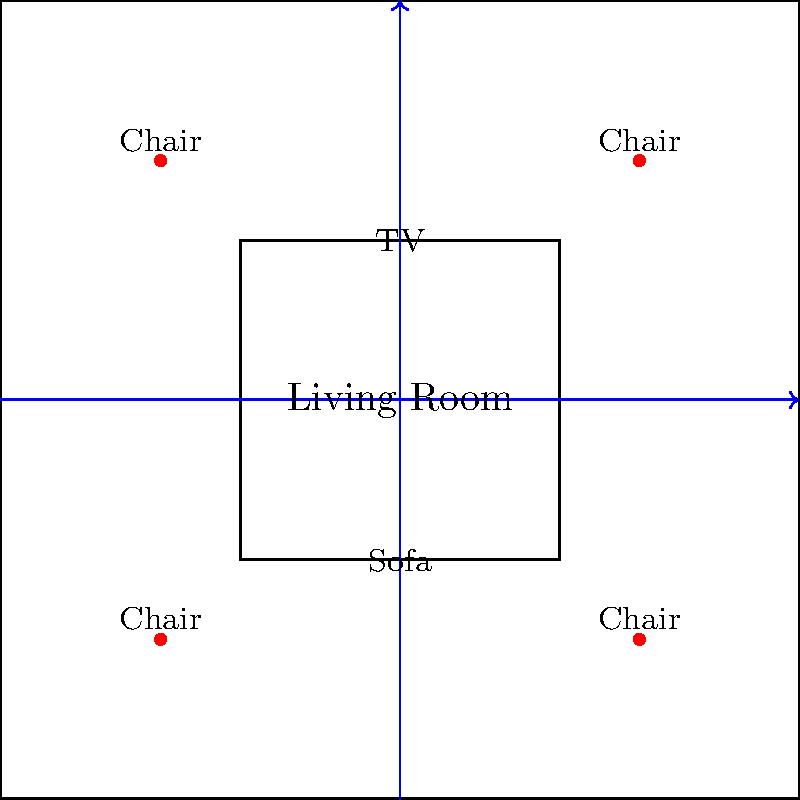In a rectangular living room measuring 100 units by 100 units, a central seating area is defined by a sofa (40 units wide) and a TV stand (40 units wide) placed opposite each other. Four chairs are positioned in the corners of the room. Given that the main traffic flow is along the two perpendicular paths that bisect the room, calculate the total area (in square units) of the optimal traffic zones to maximize flow efficiency while maintaining the current furniture layout. To solve this problem, we'll follow these steps:

1. Identify the main traffic paths:
   The two perpendicular paths bisect the room, creating four equal quadrants.

2. Determine the width of the traffic paths:
   Given the room dimensions and furniture placement, we can assume a reasonable width for the traffic paths. Let's use 20 units, which allows comfortable passage without disturbing the seating arrangement.

3. Calculate the area of the traffic zones:
   a) Area of horizontal path = 100 units × 20 units = 2000 square units
   b) Area of vertical path = 100 units × 20 units = 2000 square units
   c) However, the intersection of these paths is counted twice, so we need to subtract it:
      Intersection area = 20 units × 20 units = 400 square units

4. Calculate the total optimal traffic zone area:
   Total area = Horizontal path + Vertical path - Intersection
               = 2000 + 2000 - 400
               = 3600 square units

This layout ensures efficient traffic flow while maintaining the current furniture arrangement. The 20-unit wide paths provide enough space for people to move comfortably without interfering with the seating area or blocking access to the chairs in the corners.
Answer: 3600 square units 